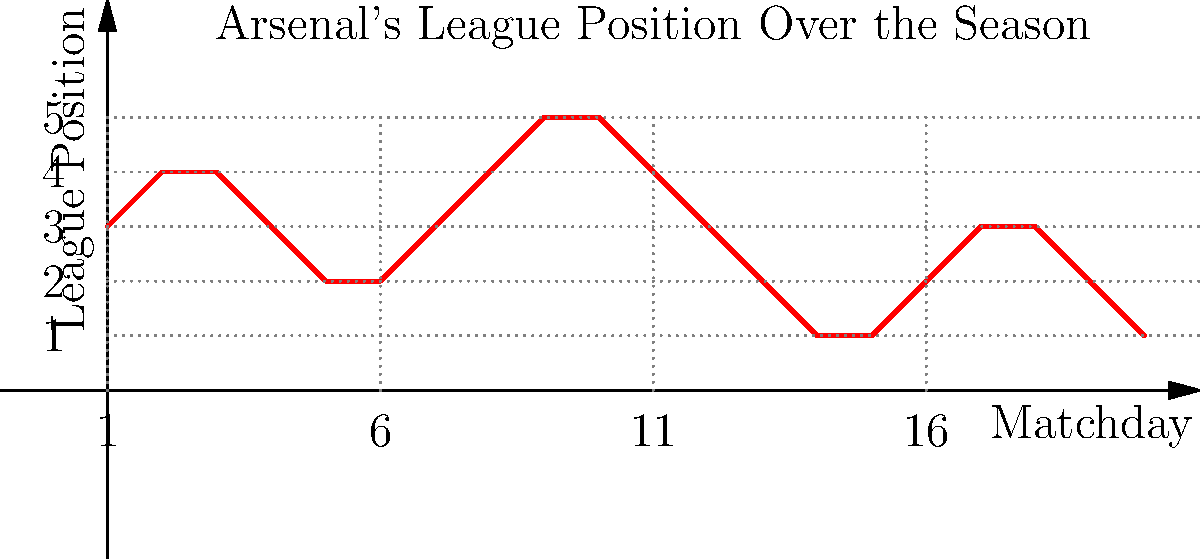Based on the graph showing Arsenal's league position over the season, what is the most likely final position for the team? To predict Arsenal's final league position, we need to analyze the trend in the graph:

1. The season starts with Arsenal in 3rd position.
2. There are fluctuations throughout the season, with positions ranging from 1st to 5th.
3. The trend in the latter half of the season is crucial:
   a. Around matchday 15, Arsenal drops to 1st position.
   b. There's a slight recovery to 3rd position around matchday 17-18.
   c. However, the final trend shows a decline, ending at 2nd position.
4. The overall trend suggests a slight decline in form towards the end of the season.
5. Given the final position of 2nd and the downward trend, it's more likely that Arsenal will maintain or slightly drop from this position rather than improve.
6. Considering the frustration factor of a typical Arsenal fan, it's reasonable to expect a finish just outside the top spot.

Therefore, based on the graph and the context of an easily frustrated Arsenal fan, the most likely final position for Arsenal would be 2nd place.
Answer: 2nd place 